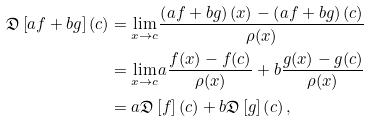<formula> <loc_0><loc_0><loc_500><loc_500>\mathfrak { D } \left [ a f + b g \right ] ( c ) & = \underset { x \rightarrow c } { \lim } \frac { \left ( a f + b g \right ) ( x ) - \left ( a f + b g \right ) ( c ) } { \rho ( x ) } \\ & = \underset { x \rightarrow c } { \lim } a \frac { f ( x ) - f ( c ) } { \rho ( x ) } + b \frac { g ( x ) - g ( c ) } { \rho ( x ) } \\ & = a \mathfrak { D } \left [ f \right ] \left ( c \right ) + b \mathfrak { D } \left [ g \right ] \left ( c \right ) ,</formula> 